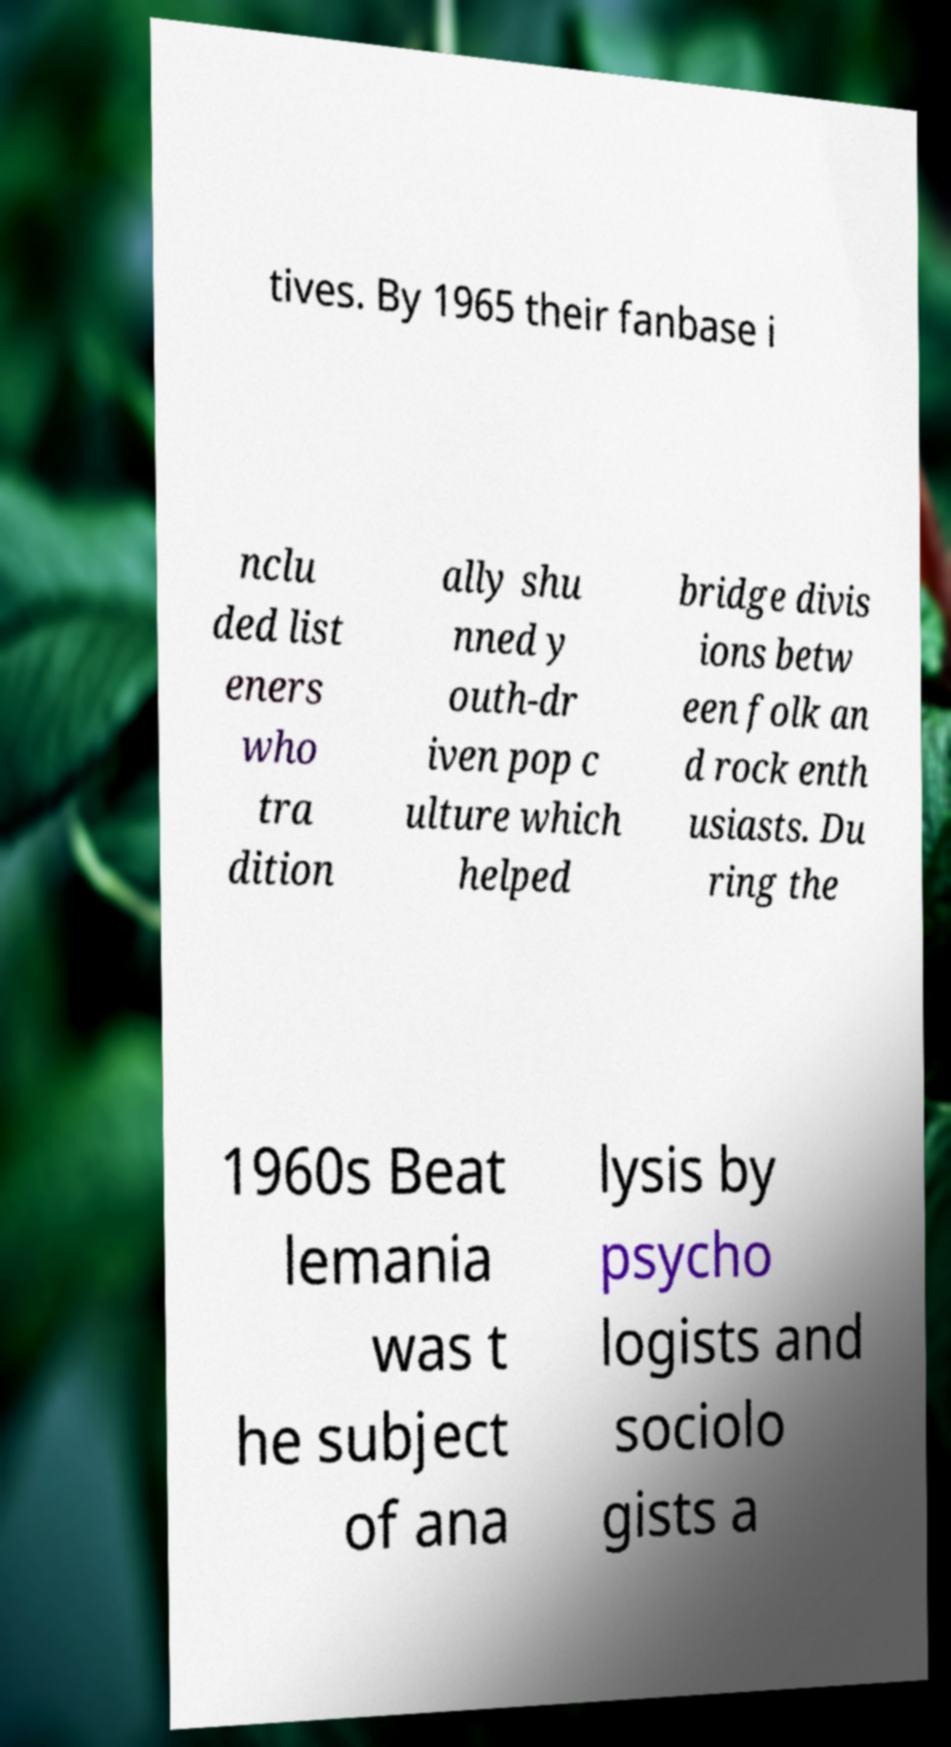Could you extract and type out the text from this image? tives. By 1965 their fanbase i nclu ded list eners who tra dition ally shu nned y outh-dr iven pop c ulture which helped bridge divis ions betw een folk an d rock enth usiasts. Du ring the 1960s Beat lemania was t he subject of ana lysis by psycho logists and sociolo gists a 